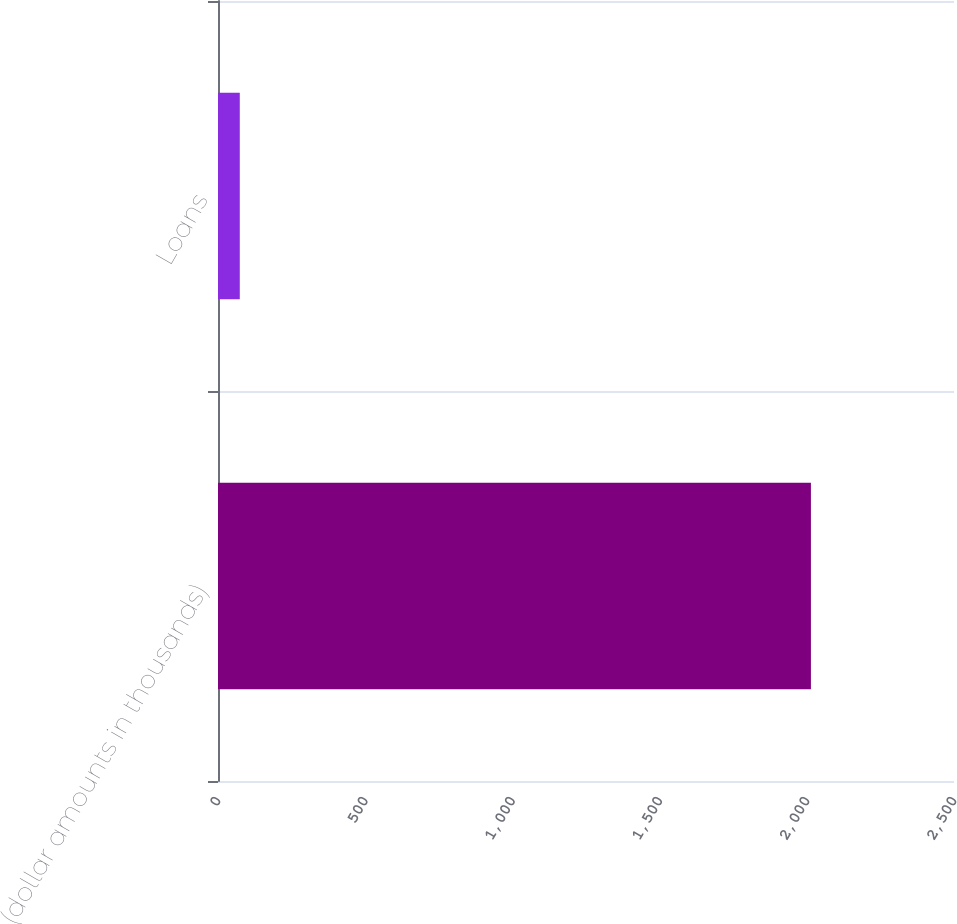Convert chart to OTSL. <chart><loc_0><loc_0><loc_500><loc_500><bar_chart><fcel>(dollar amounts in thousands)<fcel>Loans<nl><fcel>2014<fcel>74<nl></chart> 